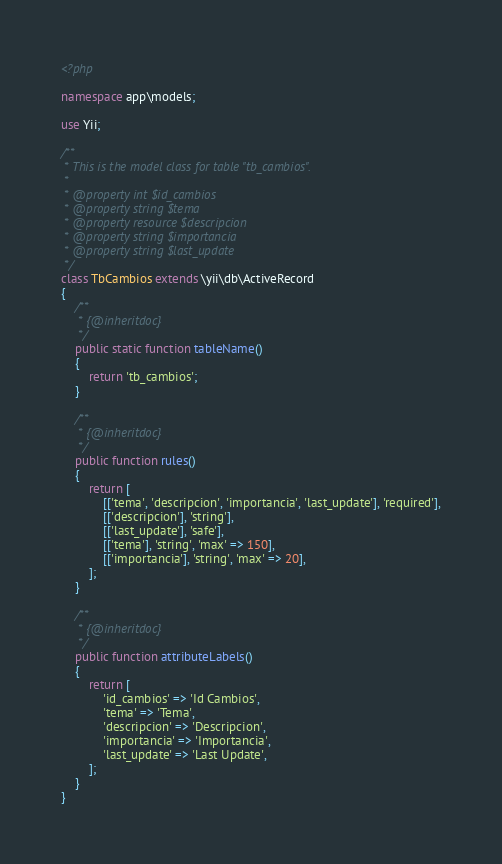<code> <loc_0><loc_0><loc_500><loc_500><_PHP_><?php

namespace app\models;

use Yii;

/**
 * This is the model class for table "tb_cambios".
 *
 * @property int $id_cambios
 * @property string $tema
 * @property resource $descripcion
 * @property string $importancia
 * @property string $last_update
 */
class TbCambios extends \yii\db\ActiveRecord
{
    /**
     * {@inheritdoc}
     */
    public static function tableName()
    {
        return 'tb_cambios';
    }

    /**
     * {@inheritdoc}
     */
    public function rules()
    {
        return [
            [['tema', 'descripcion', 'importancia', 'last_update'], 'required'],
            [['descripcion'], 'string'],
            [['last_update'], 'safe'],
            [['tema'], 'string', 'max' => 150],
            [['importancia'], 'string', 'max' => 20],
        ];
    }

    /**
     * {@inheritdoc}
     */
    public function attributeLabels()
    {
        return [
            'id_cambios' => 'Id Cambios',
            'tema' => 'Tema',
            'descripcion' => 'Descripcion',
            'importancia' => 'Importancia',
            'last_update' => 'Last Update',
        ];
    }
}
</code> 